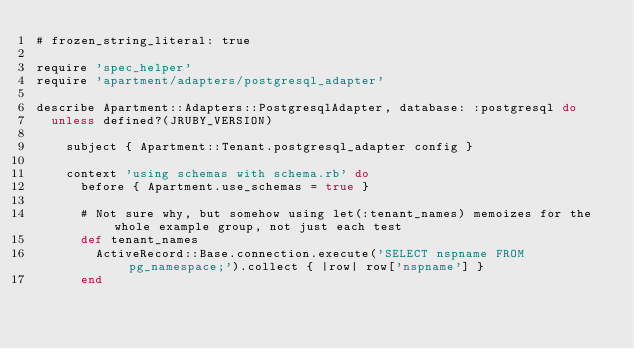<code> <loc_0><loc_0><loc_500><loc_500><_Ruby_># frozen_string_literal: true

require 'spec_helper'
require 'apartment/adapters/postgresql_adapter'

describe Apartment::Adapters::PostgresqlAdapter, database: :postgresql do
  unless defined?(JRUBY_VERSION)

    subject { Apartment::Tenant.postgresql_adapter config }

    context 'using schemas with schema.rb' do
      before { Apartment.use_schemas = true }

      # Not sure why, but somehow using let(:tenant_names) memoizes for the whole example group, not just each test
      def tenant_names
        ActiveRecord::Base.connection.execute('SELECT nspname FROM pg_namespace;').collect { |row| row['nspname'] }
      end
</code> 